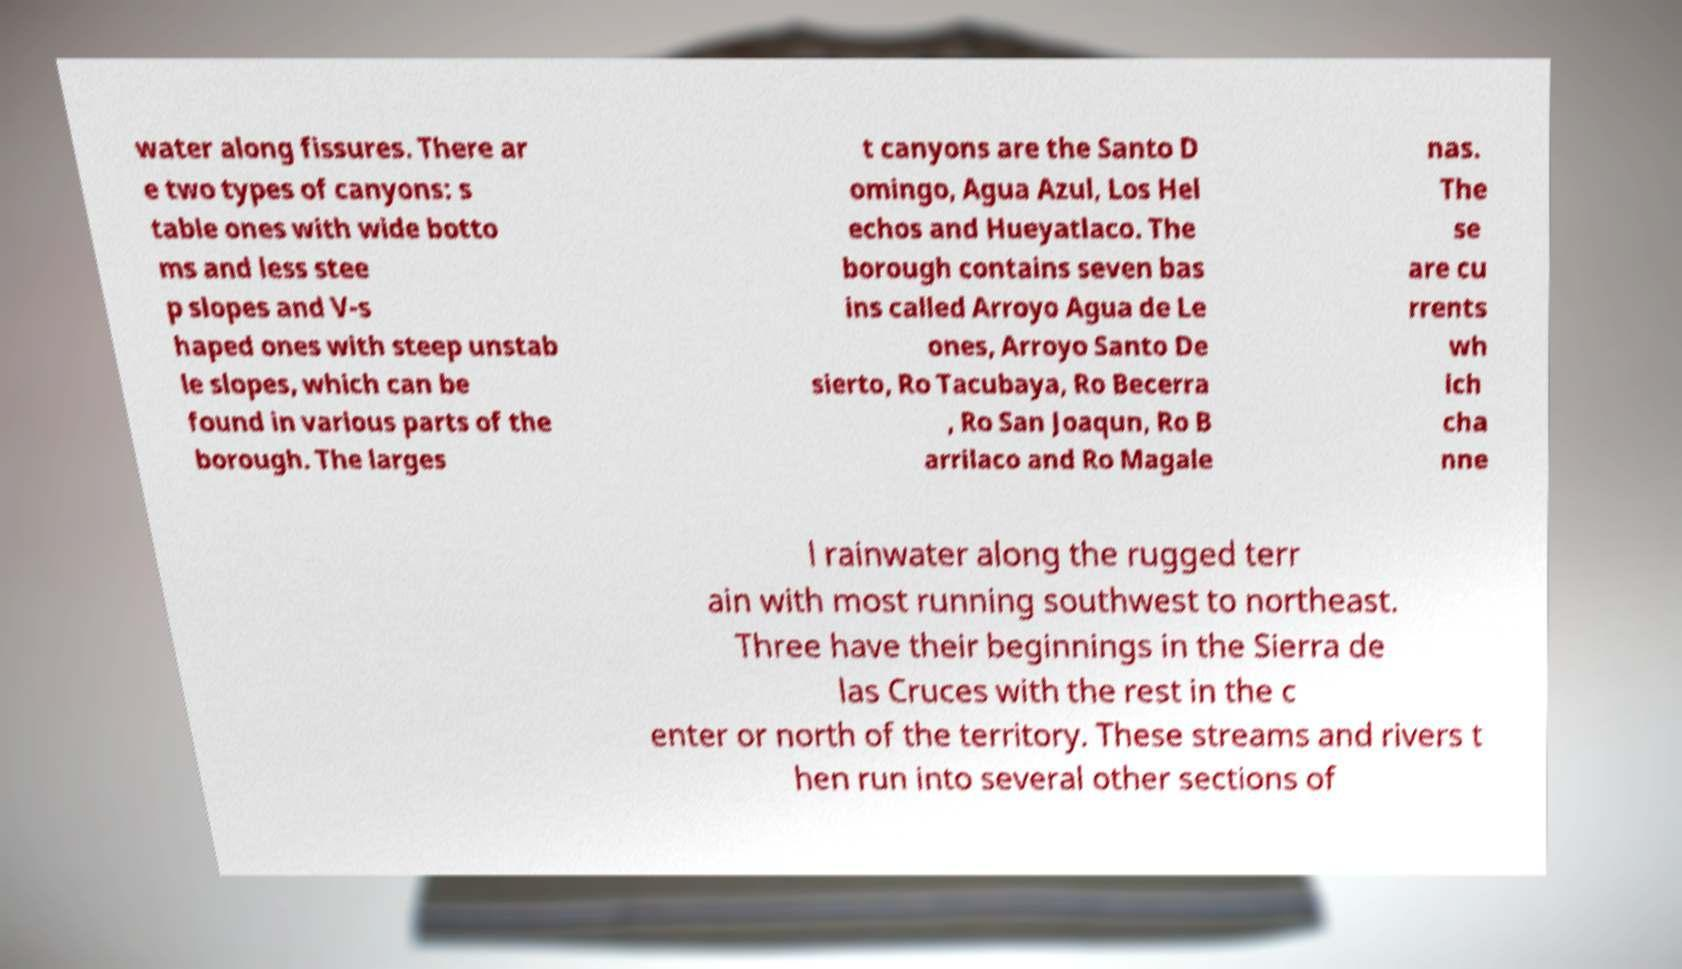Can you read and provide the text displayed in the image?This photo seems to have some interesting text. Can you extract and type it out for me? water along fissures. There ar e two types of canyons: s table ones with wide botto ms and less stee p slopes and V-s haped ones with steep unstab le slopes, which can be found in various parts of the borough. The larges t canyons are the Santo D omingo, Agua Azul, Los Hel echos and Hueyatlaco. The borough contains seven bas ins called Arroyo Agua de Le ones, Arroyo Santo De sierto, Ro Tacubaya, Ro Becerra , Ro San Joaqun, Ro B arrilaco and Ro Magale nas. The se are cu rrents wh ich cha nne l rainwater along the rugged terr ain with most running southwest to northeast. Three have their beginnings in the Sierra de las Cruces with the rest in the c enter or north of the territory. These streams and rivers t hen run into several other sections of 